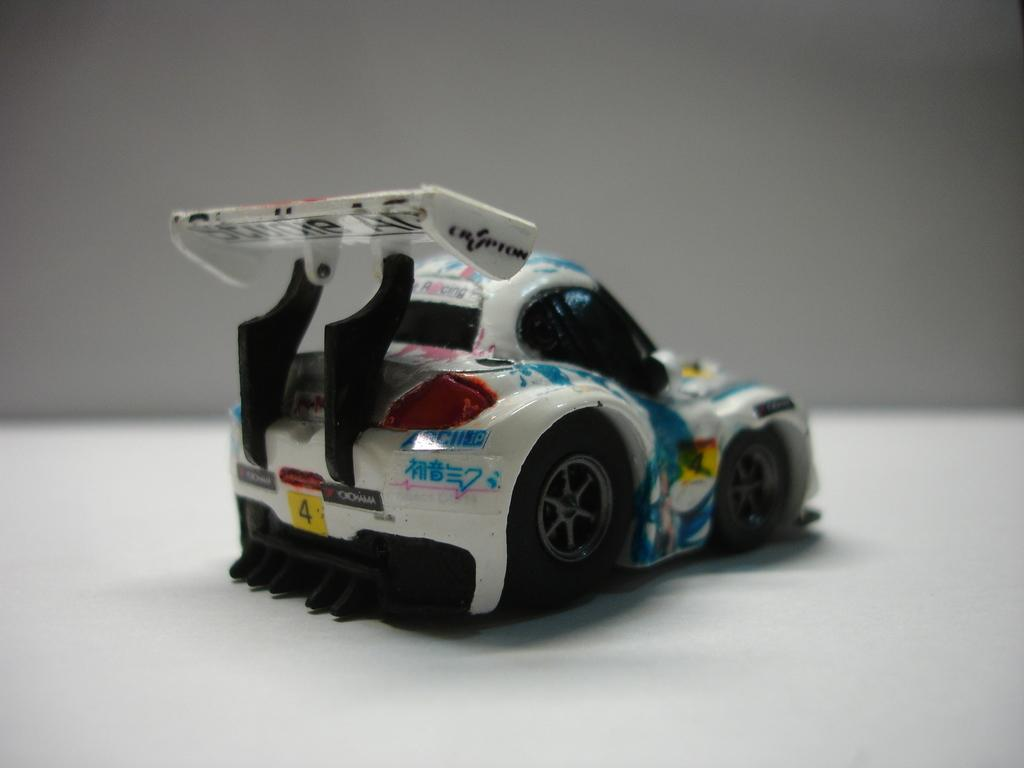What is the main subject of the image? The main subject of the image is a toy car. Where is the toy car located in the image? The toy car is on a white platform. What angle does the toy car appear to be at in the image? The angle at which the toy car is positioned cannot be determined from the image, as it appears to be straight and level. 